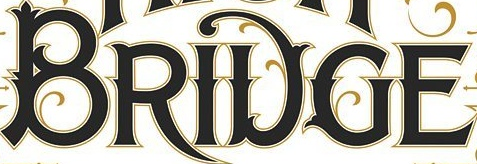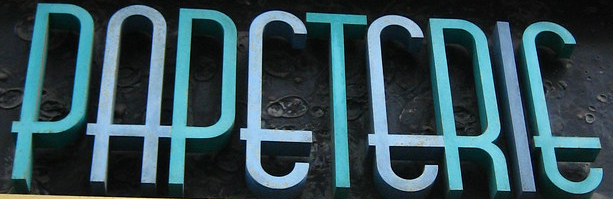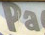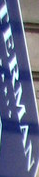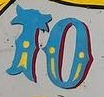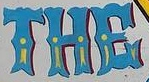What text appears in these images from left to right, separated by a semicolon? BRIDGE; PAPETERIE; Pa; TERMAN; TO; THE 